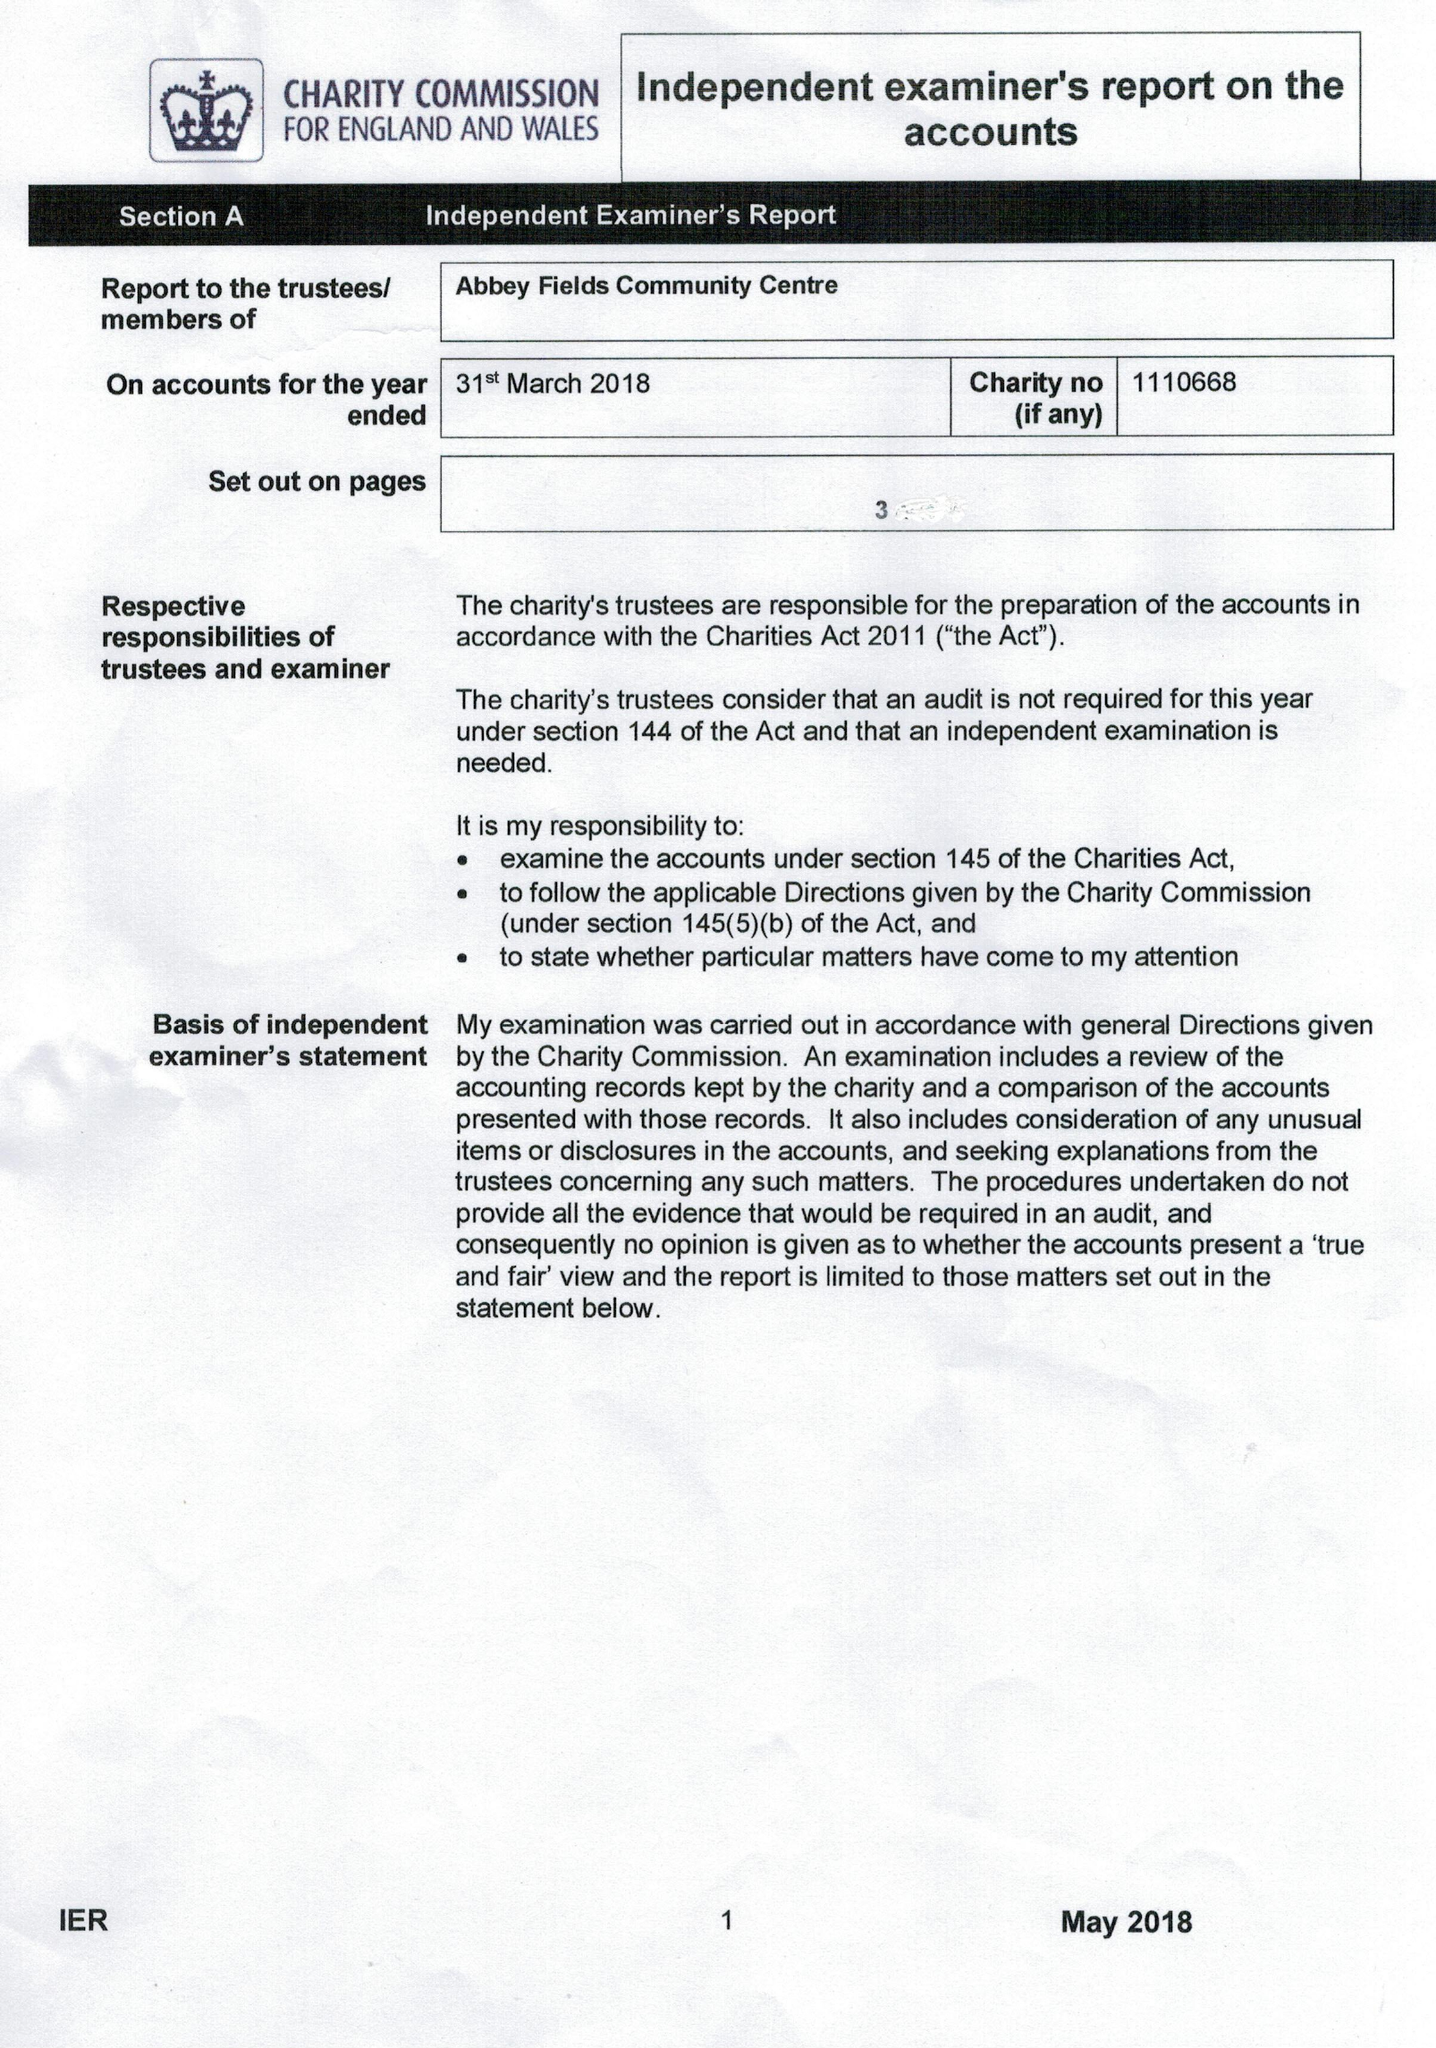What is the value for the income_annually_in_british_pounds?
Answer the question using a single word or phrase. 27002.00 